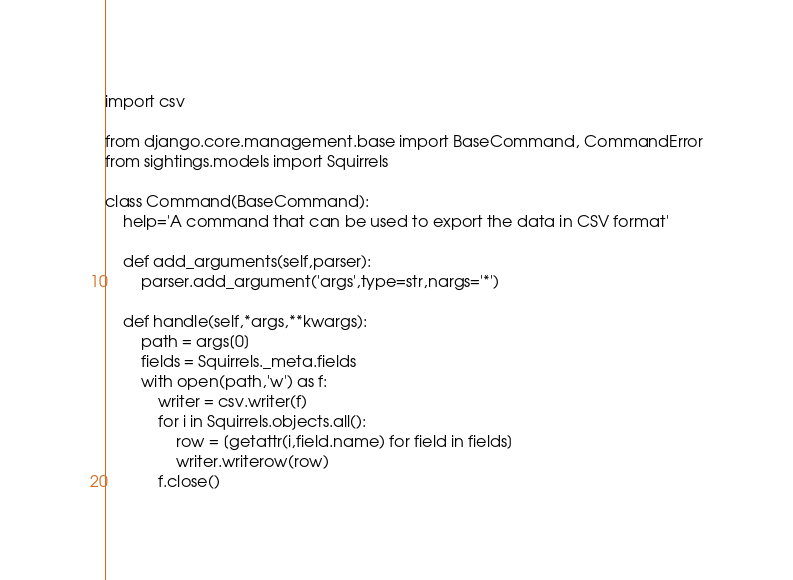Convert code to text. <code><loc_0><loc_0><loc_500><loc_500><_Python_>import csv

from django.core.management.base import BaseCommand, CommandError
from sightings.models import Squirrels

class Command(BaseCommand):
    help='A command that can be used to export the data in CSV format'

    def add_arguments(self,parser):
        parser.add_argument('args',type=str,nargs='*')

    def handle(self,*args,**kwargs):
        path = args[0]
        fields = Squirrels._meta.fields
        with open(path,'w') as f:
            writer = csv.writer(f)
            for i in Squirrels.objects.all():
                row = [getattr(i,field.name) for field in fields]
                writer.writerow(row)
            f.close()

</code> 